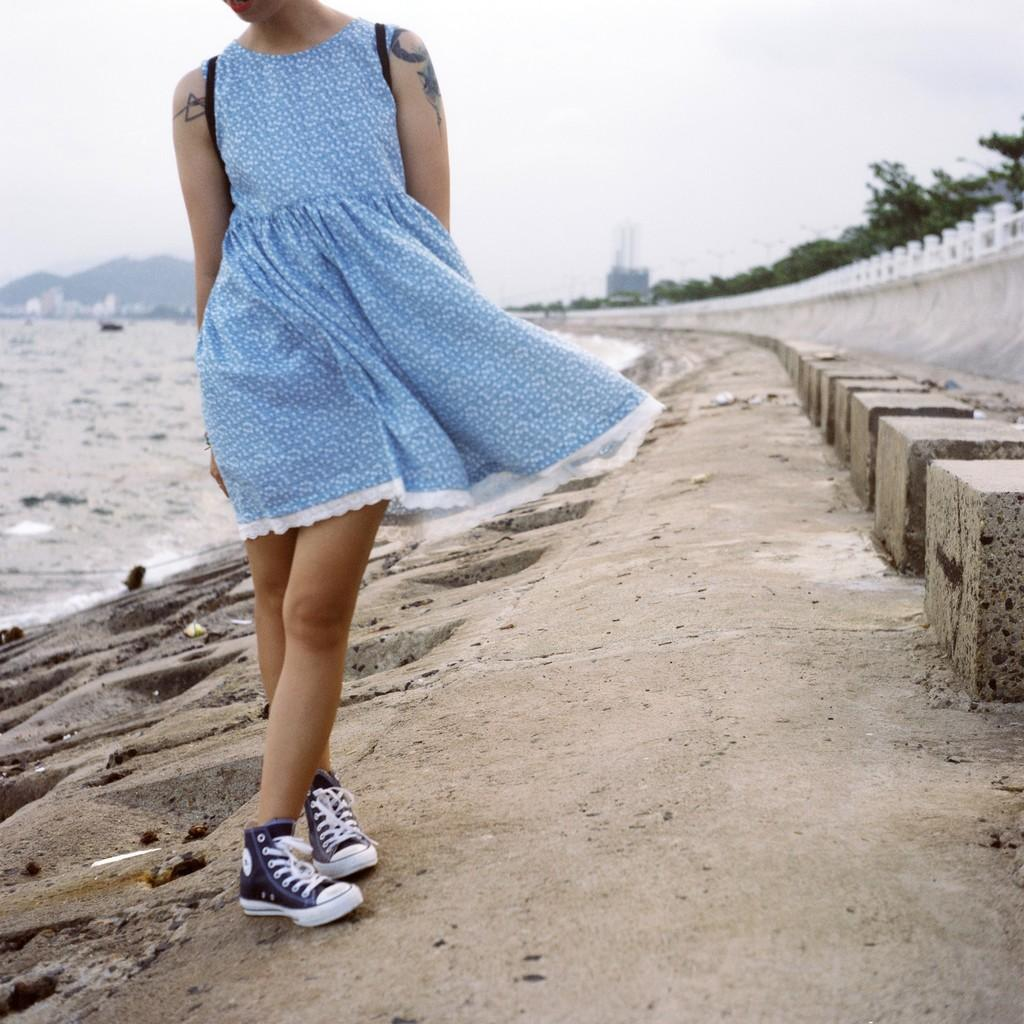What is located in the foreground of the image? There is a person in the foreground of the image. What can be seen in the background of the image? There is water, a mountain, trees, and sky visible in the background of the image. What is the surface on which the person is standing? There is a floor at the bottom of the image. What does the daughter smell in the image? There is no daughter present in the image, so it is not possible to determine what she might smell. 